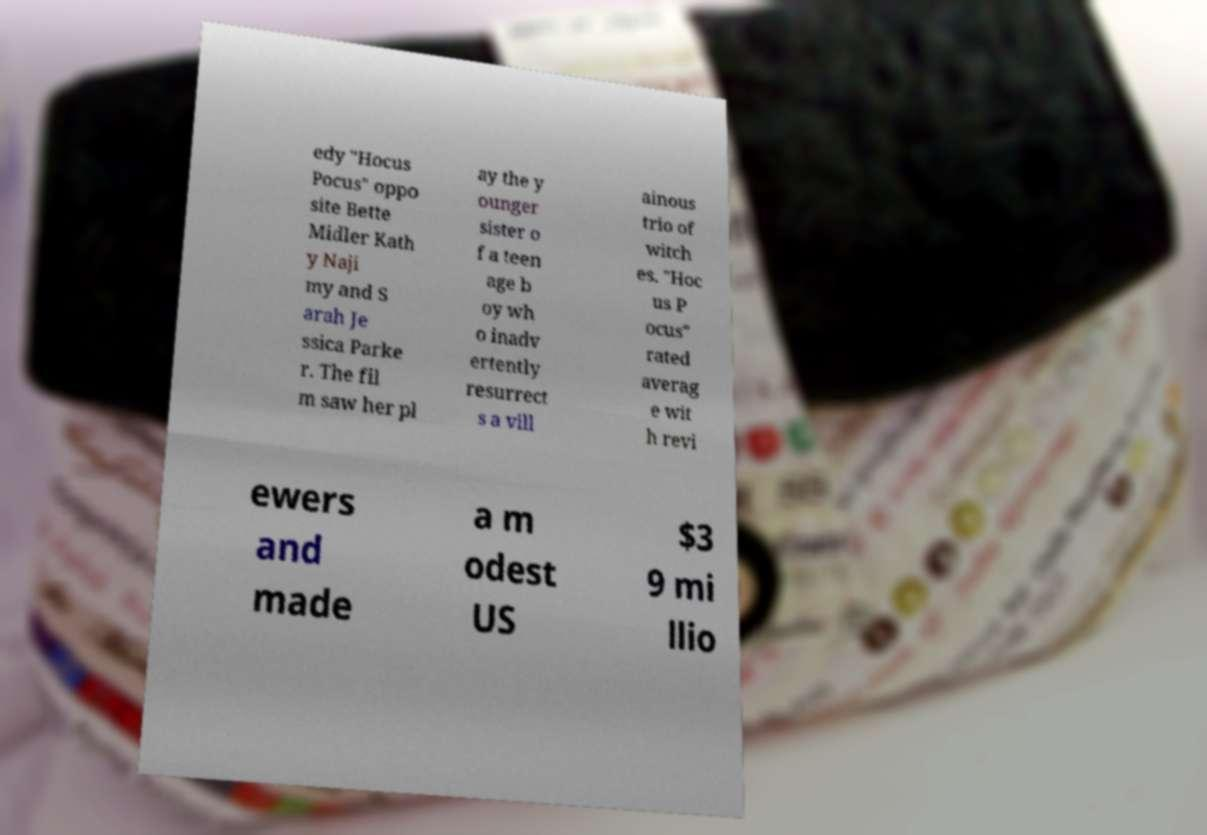Could you extract and type out the text from this image? edy "Hocus Pocus" oppo site Bette Midler Kath y Naji my and S arah Je ssica Parke r. The fil m saw her pl ay the y ounger sister o f a teen age b oy wh o inadv ertently resurrect s a vill ainous trio of witch es. "Hoc us P ocus" rated averag e wit h revi ewers and made a m odest US $3 9 mi llio 